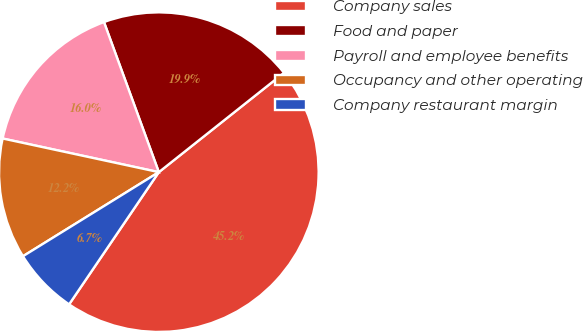<chart> <loc_0><loc_0><loc_500><loc_500><pie_chart><fcel>Company sales<fcel>Food and paper<fcel>Payroll and employee benefits<fcel>Occupancy and other operating<fcel>Company restaurant margin<nl><fcel>45.18%<fcel>19.9%<fcel>16.05%<fcel>12.2%<fcel>6.69%<nl></chart> 